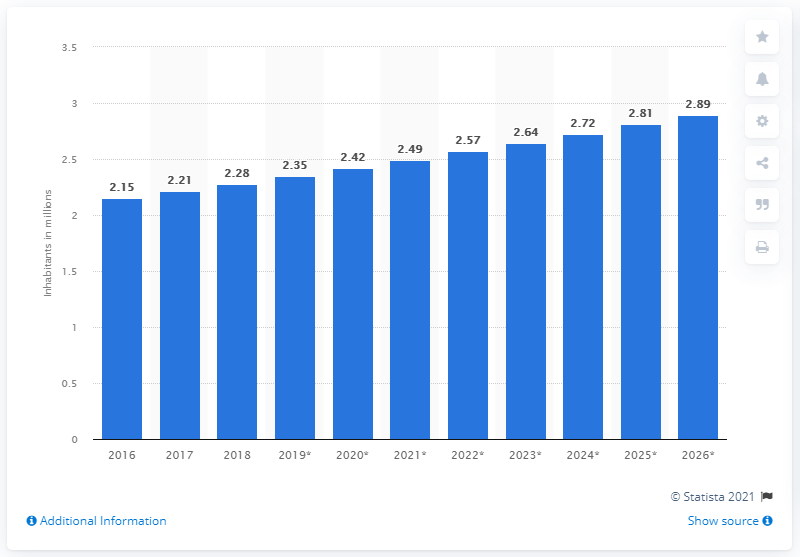Draw attention to some important aspects in this diagram. In 2018, the population of the Gambia was 2.28 million. The population of the Gambia ended in 2018. 